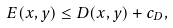Convert formula to latex. <formula><loc_0><loc_0><loc_500><loc_500>E ( x , y ) \leq D ( x , y ) + c _ { D } ,</formula> 